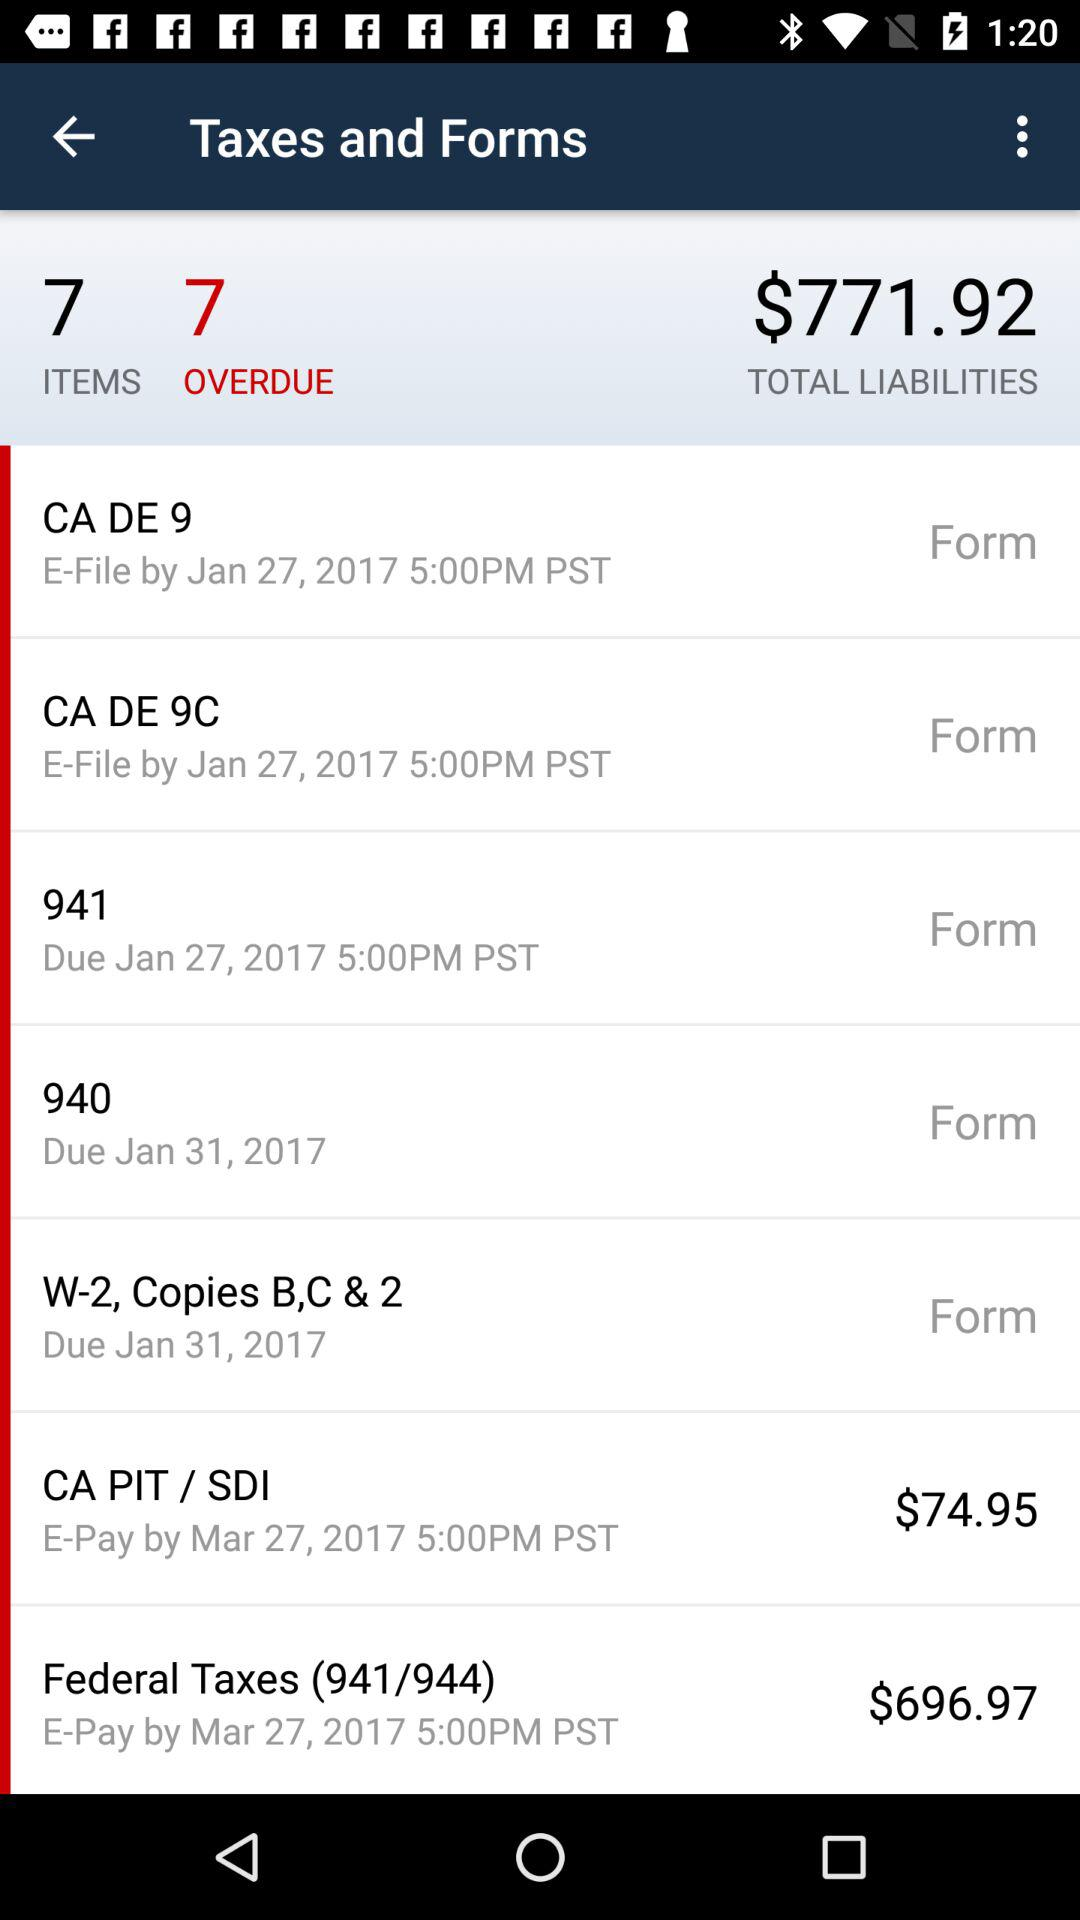What are the different tax forms available? The different tax forms available are "CA DE 9", "CA DE 9C", "941", "940", and "W-2, Copies B,C & 2". 